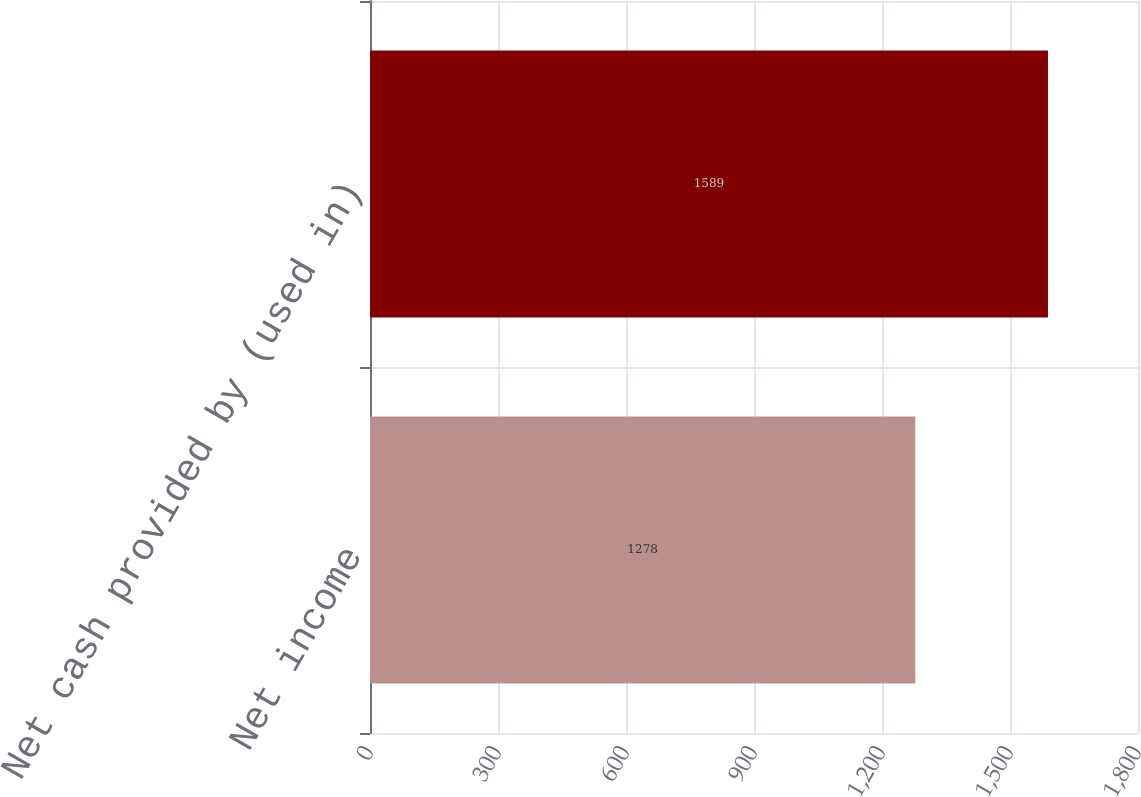Convert chart to OTSL. <chart><loc_0><loc_0><loc_500><loc_500><bar_chart><fcel>Net income<fcel>Net cash provided by (used in)<nl><fcel>1278<fcel>1589<nl></chart> 